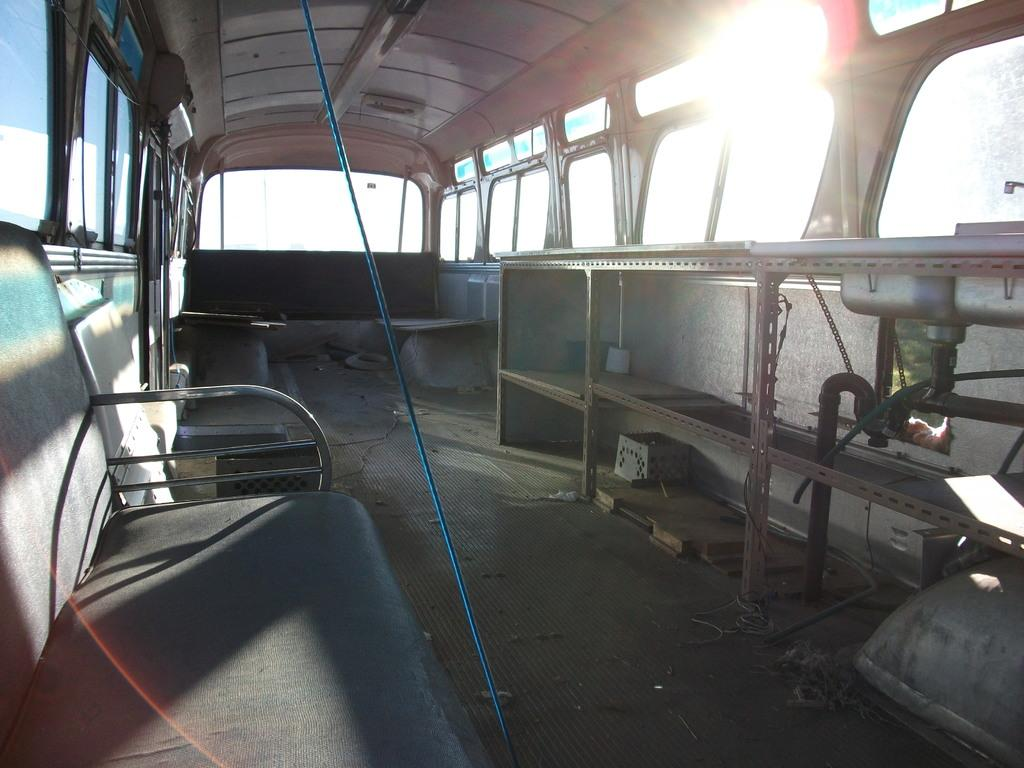What is the setting of the image? The image shows the inside of a vehicle. What type of pickle is the doctor holding in the image? There is no doctor or pickle present in the image; it shows the inside of a vehicle. 